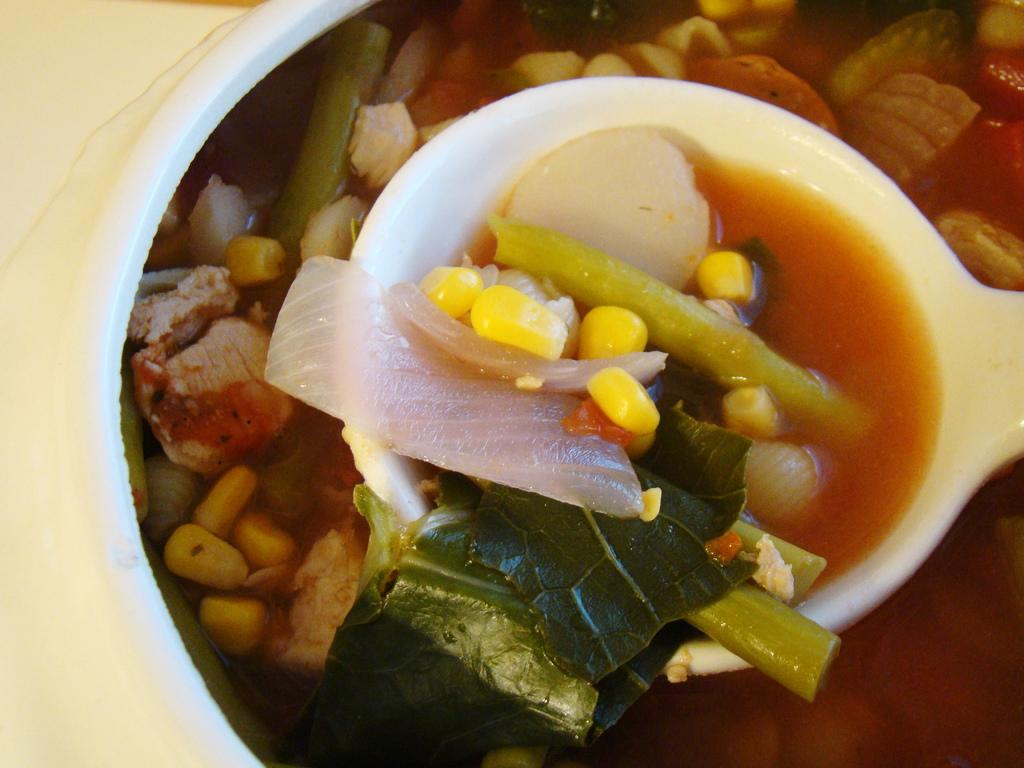What is the main subject of the image? There is a food item in the image. What utensil is present in the image? There is a spoon in the bowl in the image. What color is the surface on the left side of the image? The surface on the left side of the image is white. What type of bubble can be seen in the image? There is no bubble present in the image. What amusement activity is taking place in the image? There is no amusement activity depicted in the image. 